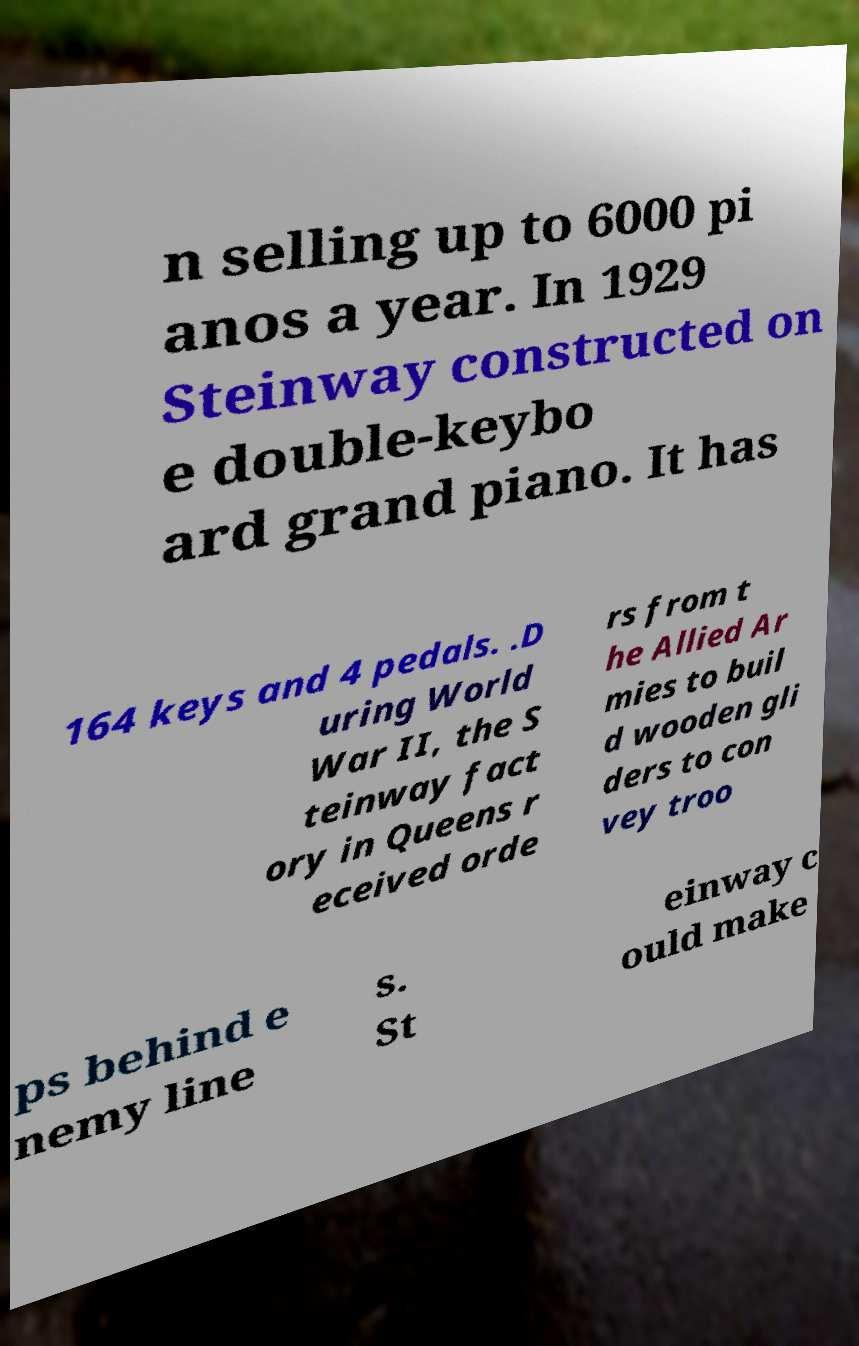Could you assist in decoding the text presented in this image and type it out clearly? n selling up to 6000 pi anos a year. In 1929 Steinway constructed on e double-keybo ard grand piano. It has 164 keys and 4 pedals. .D uring World War II, the S teinway fact ory in Queens r eceived orde rs from t he Allied Ar mies to buil d wooden gli ders to con vey troo ps behind e nemy line s. St einway c ould make 